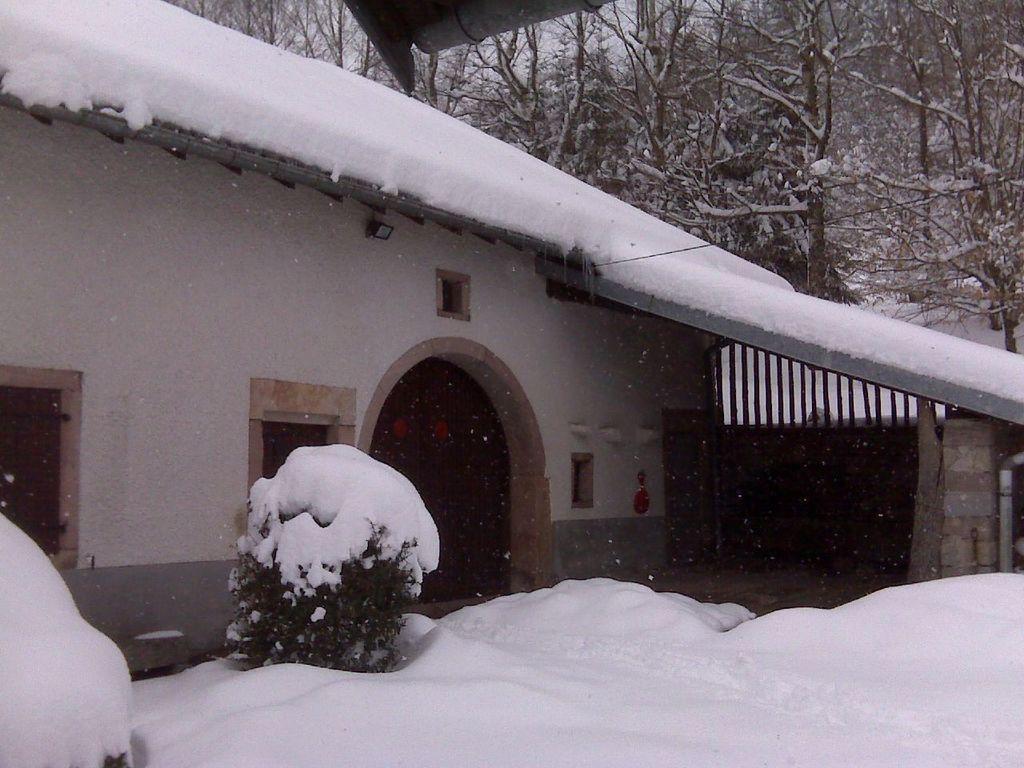How would you summarize this image in a sentence or two? In this image in the center there is one houses and and some plants, and plants are covered with snow. At the bottom there is a snow, and in the background there are some trees. 